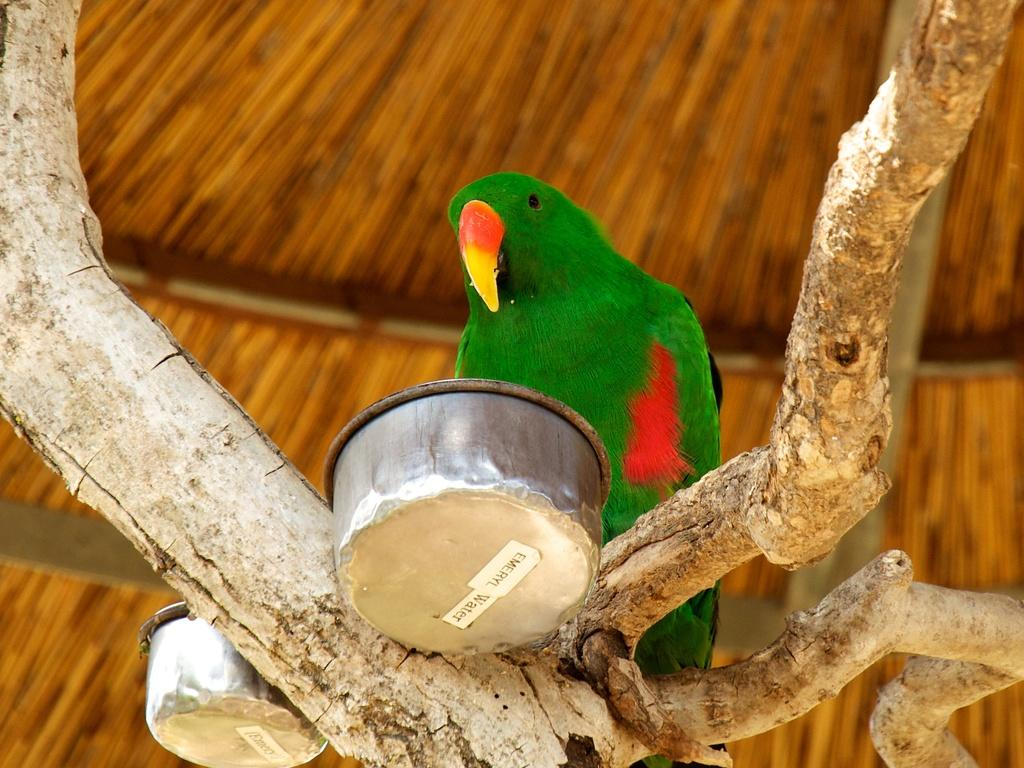What type of animal can be seen in the image? There is a bird in the image. Where is the bird located? The bird is on a branch. What other objects are present in the image? There are bowls and stickers in the image. What architectural feature is visible in the image? There is a roof visible in the image. What type of picture is the bird holding in the image? There is no picture or mention of a pickle in the image; it features a bird on a branch, bowls, stickers, and a roof. 